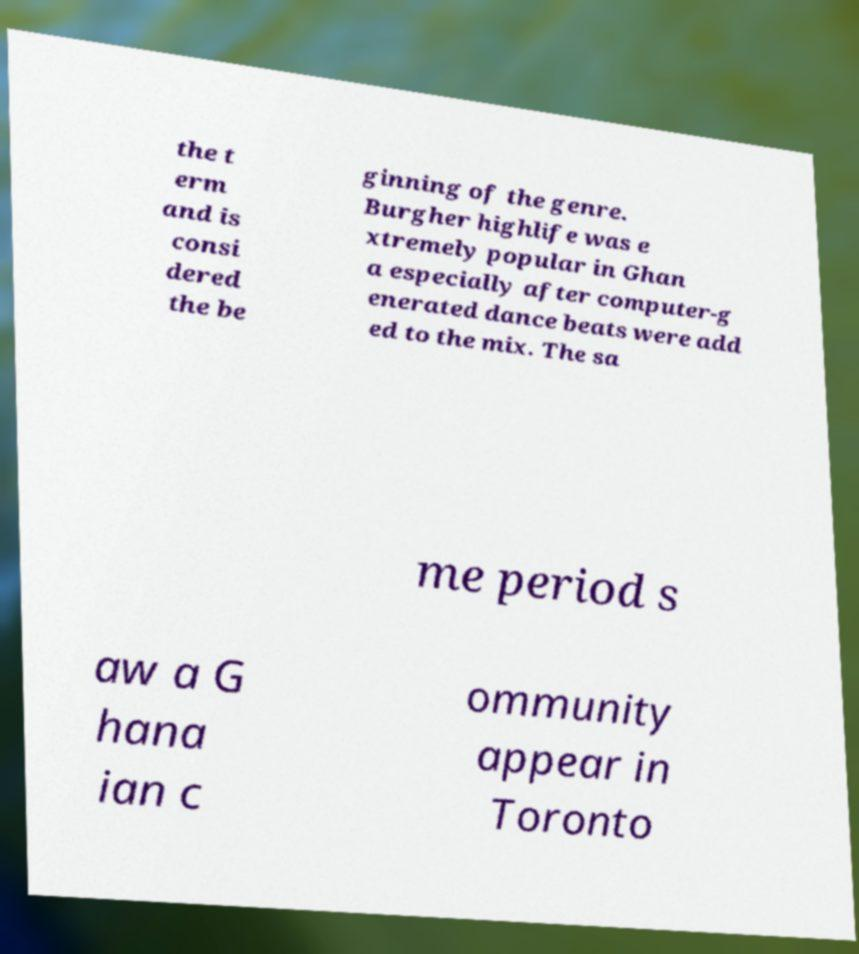Please read and relay the text visible in this image. What does it say? the t erm and is consi dered the be ginning of the genre. Burgher highlife was e xtremely popular in Ghan a especially after computer-g enerated dance beats were add ed to the mix. The sa me period s aw a G hana ian c ommunity appear in Toronto 